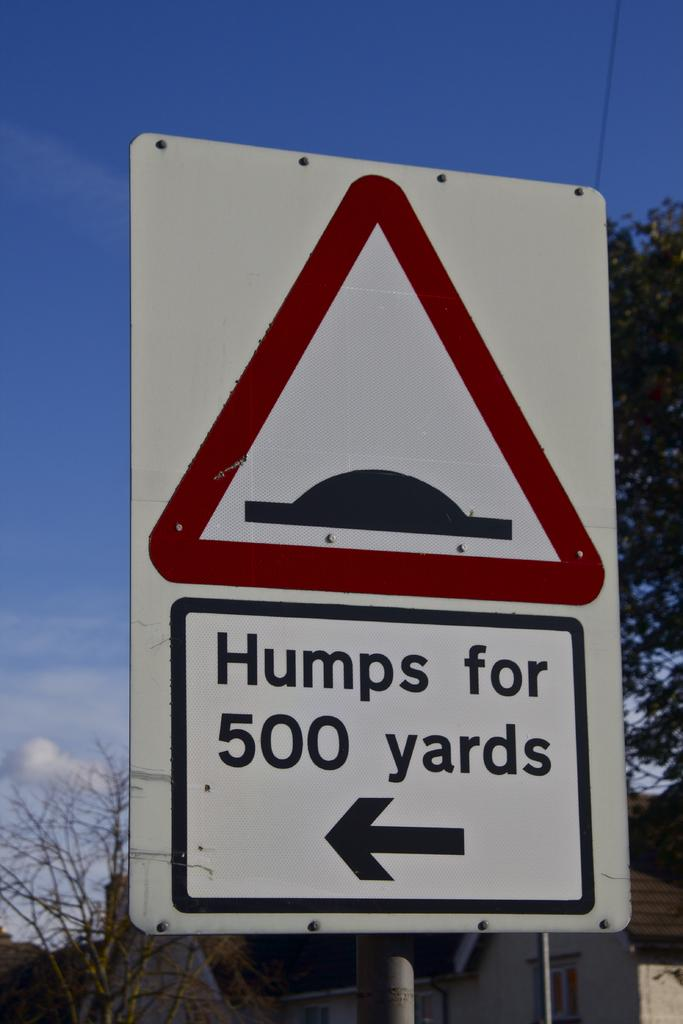<image>
Render a clear and concise summary of the photo. A red triangle sign on top and underneath the word Humps for 500 yards on it. 